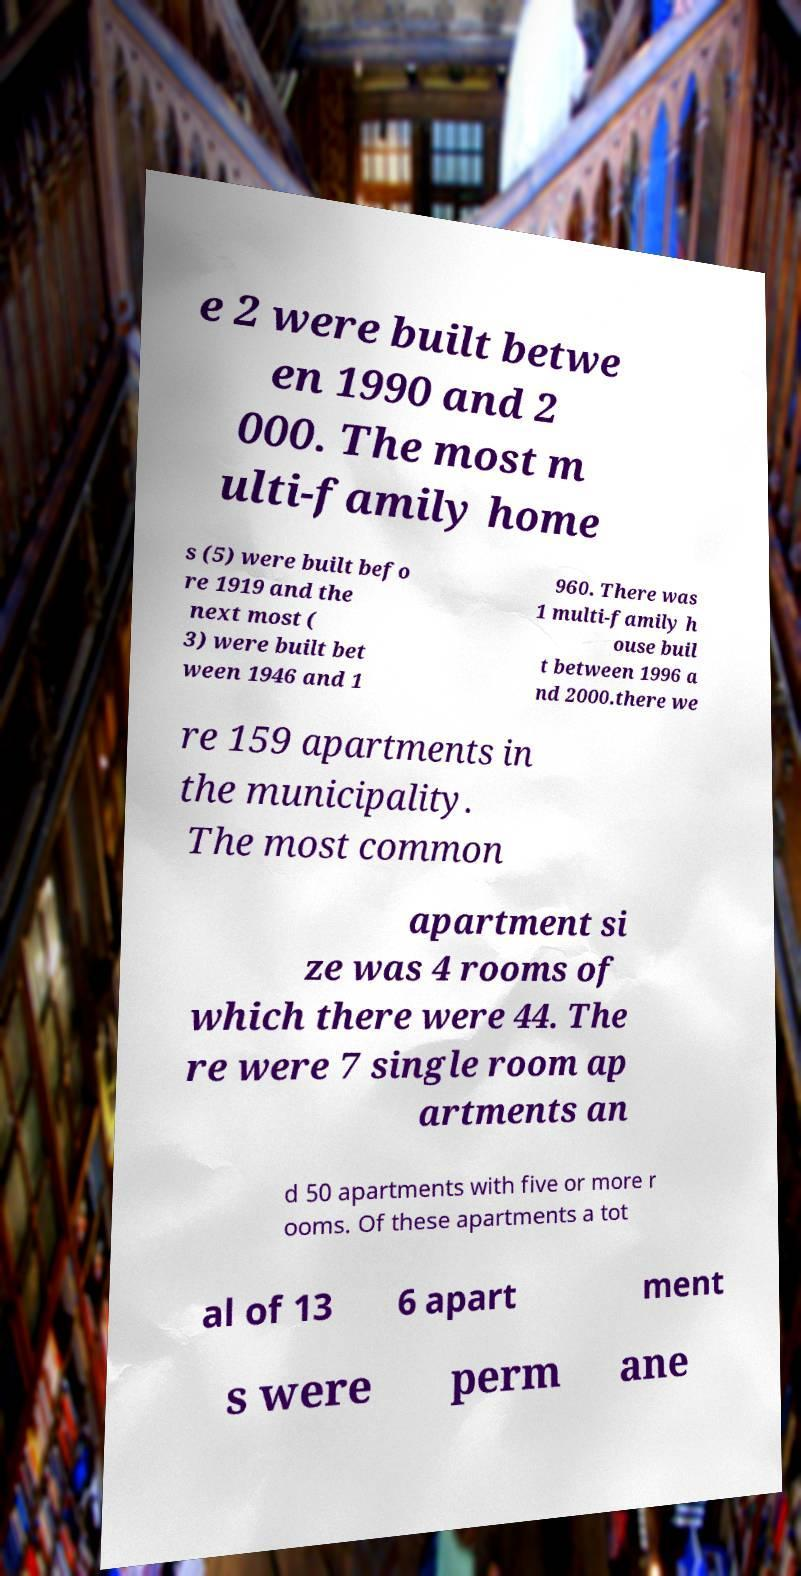Can you accurately transcribe the text from the provided image for me? e 2 were built betwe en 1990 and 2 000. The most m ulti-family home s (5) were built befo re 1919 and the next most ( 3) were built bet ween 1946 and 1 960. There was 1 multi-family h ouse buil t between 1996 a nd 2000.there we re 159 apartments in the municipality. The most common apartment si ze was 4 rooms of which there were 44. The re were 7 single room ap artments an d 50 apartments with five or more r ooms. Of these apartments a tot al of 13 6 apart ment s were perm ane 